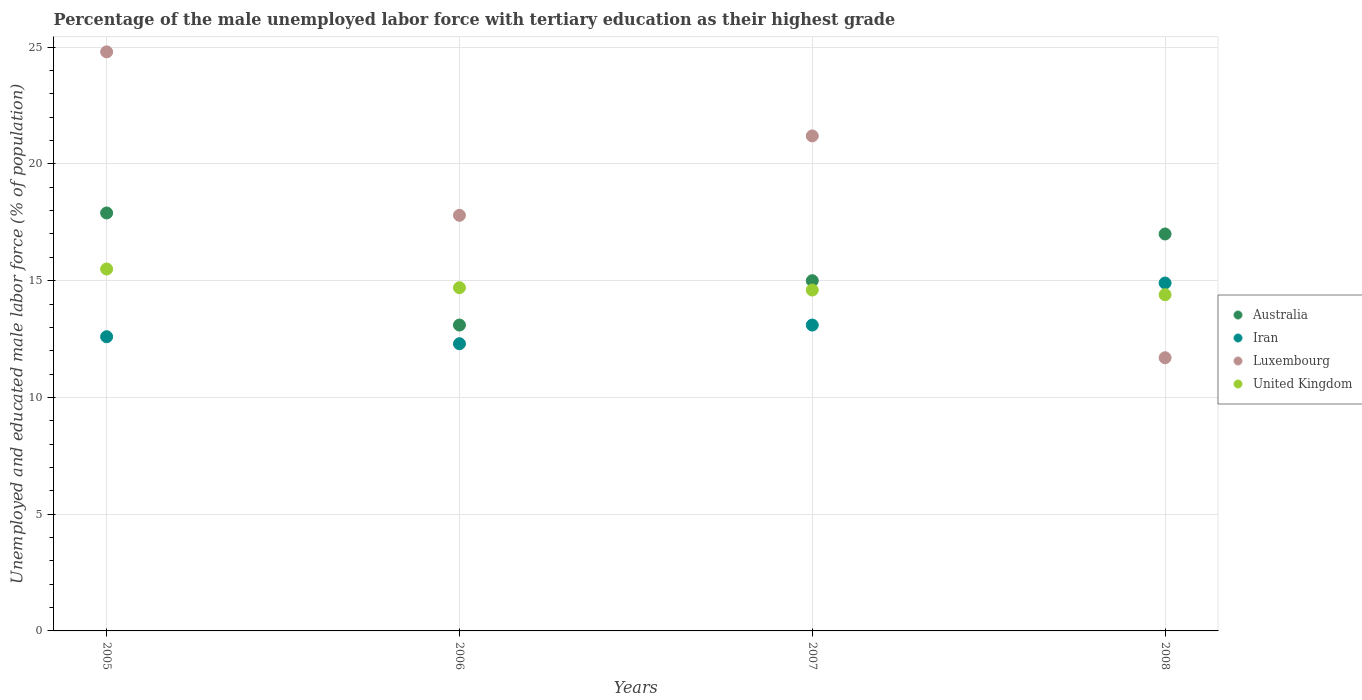How many different coloured dotlines are there?
Keep it short and to the point. 4. Is the number of dotlines equal to the number of legend labels?
Provide a short and direct response. Yes. What is the percentage of the unemployed male labor force with tertiary education in Luxembourg in 2008?
Your answer should be compact. 11.7. Across all years, what is the maximum percentage of the unemployed male labor force with tertiary education in Iran?
Make the answer very short. 14.9. Across all years, what is the minimum percentage of the unemployed male labor force with tertiary education in Iran?
Your answer should be very brief. 12.3. What is the total percentage of the unemployed male labor force with tertiary education in Iran in the graph?
Provide a succinct answer. 52.9. What is the difference between the percentage of the unemployed male labor force with tertiary education in United Kingdom in 2006 and that in 2008?
Provide a succinct answer. 0.3. What is the difference between the percentage of the unemployed male labor force with tertiary education in Iran in 2005 and the percentage of the unemployed male labor force with tertiary education in Luxembourg in 2007?
Ensure brevity in your answer.  -8.6. What is the average percentage of the unemployed male labor force with tertiary education in Australia per year?
Make the answer very short. 15.75. In the year 2008, what is the difference between the percentage of the unemployed male labor force with tertiary education in United Kingdom and percentage of the unemployed male labor force with tertiary education in Iran?
Offer a terse response. -0.5. What is the ratio of the percentage of the unemployed male labor force with tertiary education in Luxembourg in 2007 to that in 2008?
Give a very brief answer. 1.81. What is the difference between the highest and the second highest percentage of the unemployed male labor force with tertiary education in Iran?
Ensure brevity in your answer.  1.8. What is the difference between the highest and the lowest percentage of the unemployed male labor force with tertiary education in Iran?
Give a very brief answer. 2.6. Is the sum of the percentage of the unemployed male labor force with tertiary education in Luxembourg in 2006 and 2008 greater than the maximum percentage of the unemployed male labor force with tertiary education in United Kingdom across all years?
Your response must be concise. Yes. Is it the case that in every year, the sum of the percentage of the unemployed male labor force with tertiary education in United Kingdom and percentage of the unemployed male labor force with tertiary education in Luxembourg  is greater than the percentage of the unemployed male labor force with tertiary education in Australia?
Provide a succinct answer. Yes. Does the percentage of the unemployed male labor force with tertiary education in United Kingdom monotonically increase over the years?
Ensure brevity in your answer.  No. Is the percentage of the unemployed male labor force with tertiary education in Australia strictly greater than the percentage of the unemployed male labor force with tertiary education in Luxembourg over the years?
Your response must be concise. No. How many dotlines are there?
Provide a short and direct response. 4. How many years are there in the graph?
Provide a short and direct response. 4. What is the difference between two consecutive major ticks on the Y-axis?
Keep it short and to the point. 5. Are the values on the major ticks of Y-axis written in scientific E-notation?
Ensure brevity in your answer.  No. Does the graph contain grids?
Ensure brevity in your answer.  Yes. How are the legend labels stacked?
Keep it short and to the point. Vertical. What is the title of the graph?
Your answer should be very brief. Percentage of the male unemployed labor force with tertiary education as their highest grade. Does "Estonia" appear as one of the legend labels in the graph?
Give a very brief answer. No. What is the label or title of the X-axis?
Ensure brevity in your answer.  Years. What is the label or title of the Y-axis?
Your response must be concise. Unemployed and educated male labor force (% of population). What is the Unemployed and educated male labor force (% of population) of Australia in 2005?
Provide a succinct answer. 17.9. What is the Unemployed and educated male labor force (% of population) in Iran in 2005?
Your response must be concise. 12.6. What is the Unemployed and educated male labor force (% of population) in Luxembourg in 2005?
Give a very brief answer. 24.8. What is the Unemployed and educated male labor force (% of population) in United Kingdom in 2005?
Keep it short and to the point. 15.5. What is the Unemployed and educated male labor force (% of population) of Australia in 2006?
Ensure brevity in your answer.  13.1. What is the Unemployed and educated male labor force (% of population) in Iran in 2006?
Provide a short and direct response. 12.3. What is the Unemployed and educated male labor force (% of population) of Luxembourg in 2006?
Provide a succinct answer. 17.8. What is the Unemployed and educated male labor force (% of population) of United Kingdom in 2006?
Make the answer very short. 14.7. What is the Unemployed and educated male labor force (% of population) in Iran in 2007?
Ensure brevity in your answer.  13.1. What is the Unemployed and educated male labor force (% of population) of Luxembourg in 2007?
Offer a terse response. 21.2. What is the Unemployed and educated male labor force (% of population) of United Kingdom in 2007?
Make the answer very short. 14.6. What is the Unemployed and educated male labor force (% of population) of Australia in 2008?
Offer a very short reply. 17. What is the Unemployed and educated male labor force (% of population) of Iran in 2008?
Your answer should be very brief. 14.9. What is the Unemployed and educated male labor force (% of population) in Luxembourg in 2008?
Give a very brief answer. 11.7. What is the Unemployed and educated male labor force (% of population) of United Kingdom in 2008?
Offer a very short reply. 14.4. Across all years, what is the maximum Unemployed and educated male labor force (% of population) in Australia?
Your response must be concise. 17.9. Across all years, what is the maximum Unemployed and educated male labor force (% of population) in Iran?
Your response must be concise. 14.9. Across all years, what is the maximum Unemployed and educated male labor force (% of population) in Luxembourg?
Keep it short and to the point. 24.8. Across all years, what is the maximum Unemployed and educated male labor force (% of population) of United Kingdom?
Your answer should be compact. 15.5. Across all years, what is the minimum Unemployed and educated male labor force (% of population) of Australia?
Give a very brief answer. 13.1. Across all years, what is the minimum Unemployed and educated male labor force (% of population) in Iran?
Keep it short and to the point. 12.3. Across all years, what is the minimum Unemployed and educated male labor force (% of population) in Luxembourg?
Make the answer very short. 11.7. Across all years, what is the minimum Unemployed and educated male labor force (% of population) of United Kingdom?
Keep it short and to the point. 14.4. What is the total Unemployed and educated male labor force (% of population) of Australia in the graph?
Provide a short and direct response. 63. What is the total Unemployed and educated male labor force (% of population) of Iran in the graph?
Offer a terse response. 52.9. What is the total Unemployed and educated male labor force (% of population) in Luxembourg in the graph?
Provide a succinct answer. 75.5. What is the total Unemployed and educated male labor force (% of population) in United Kingdom in the graph?
Provide a succinct answer. 59.2. What is the difference between the Unemployed and educated male labor force (% of population) of Australia in 2005 and that in 2006?
Make the answer very short. 4.8. What is the difference between the Unemployed and educated male labor force (% of population) of United Kingdom in 2005 and that in 2007?
Keep it short and to the point. 0.9. What is the difference between the Unemployed and educated male labor force (% of population) of Australia in 2005 and that in 2008?
Keep it short and to the point. 0.9. What is the difference between the Unemployed and educated male labor force (% of population) of Luxembourg in 2005 and that in 2008?
Give a very brief answer. 13.1. What is the difference between the Unemployed and educated male labor force (% of population) in Iran in 2005 and the Unemployed and educated male labor force (% of population) in Luxembourg in 2006?
Provide a succinct answer. -5.2. What is the difference between the Unemployed and educated male labor force (% of population) of Luxembourg in 2005 and the Unemployed and educated male labor force (% of population) of United Kingdom in 2006?
Keep it short and to the point. 10.1. What is the difference between the Unemployed and educated male labor force (% of population) in Australia in 2005 and the Unemployed and educated male labor force (% of population) in Iran in 2007?
Keep it short and to the point. 4.8. What is the difference between the Unemployed and educated male labor force (% of population) in Australia in 2005 and the Unemployed and educated male labor force (% of population) in Luxembourg in 2007?
Your answer should be compact. -3.3. What is the difference between the Unemployed and educated male labor force (% of population) of Australia in 2005 and the Unemployed and educated male labor force (% of population) of United Kingdom in 2007?
Ensure brevity in your answer.  3.3. What is the difference between the Unemployed and educated male labor force (% of population) in Iran in 2005 and the Unemployed and educated male labor force (% of population) in United Kingdom in 2007?
Offer a terse response. -2. What is the difference between the Unemployed and educated male labor force (% of population) of Australia in 2005 and the Unemployed and educated male labor force (% of population) of Iran in 2008?
Offer a very short reply. 3. What is the difference between the Unemployed and educated male labor force (% of population) in Australia in 2005 and the Unemployed and educated male labor force (% of population) in United Kingdom in 2008?
Your answer should be very brief. 3.5. What is the difference between the Unemployed and educated male labor force (% of population) in Australia in 2006 and the Unemployed and educated male labor force (% of population) in Iran in 2007?
Keep it short and to the point. 0. What is the difference between the Unemployed and educated male labor force (% of population) of Luxembourg in 2006 and the Unemployed and educated male labor force (% of population) of United Kingdom in 2008?
Provide a short and direct response. 3.4. What is the difference between the Unemployed and educated male labor force (% of population) in Australia in 2007 and the Unemployed and educated male labor force (% of population) in Luxembourg in 2008?
Your response must be concise. 3.3. What is the difference between the Unemployed and educated male labor force (% of population) of Australia in 2007 and the Unemployed and educated male labor force (% of population) of United Kingdom in 2008?
Your response must be concise. 0.6. What is the difference between the Unemployed and educated male labor force (% of population) in Iran in 2007 and the Unemployed and educated male labor force (% of population) in Luxembourg in 2008?
Make the answer very short. 1.4. What is the difference between the Unemployed and educated male labor force (% of population) in Iran in 2007 and the Unemployed and educated male labor force (% of population) in United Kingdom in 2008?
Provide a succinct answer. -1.3. What is the difference between the Unemployed and educated male labor force (% of population) of Luxembourg in 2007 and the Unemployed and educated male labor force (% of population) of United Kingdom in 2008?
Offer a terse response. 6.8. What is the average Unemployed and educated male labor force (% of population) in Australia per year?
Your answer should be very brief. 15.75. What is the average Unemployed and educated male labor force (% of population) of Iran per year?
Give a very brief answer. 13.22. What is the average Unemployed and educated male labor force (% of population) of Luxembourg per year?
Make the answer very short. 18.88. What is the average Unemployed and educated male labor force (% of population) in United Kingdom per year?
Your answer should be compact. 14.8. In the year 2005, what is the difference between the Unemployed and educated male labor force (% of population) in Australia and Unemployed and educated male labor force (% of population) in Iran?
Ensure brevity in your answer.  5.3. In the year 2005, what is the difference between the Unemployed and educated male labor force (% of population) in Australia and Unemployed and educated male labor force (% of population) in Luxembourg?
Provide a short and direct response. -6.9. In the year 2005, what is the difference between the Unemployed and educated male labor force (% of population) in Australia and Unemployed and educated male labor force (% of population) in United Kingdom?
Your answer should be compact. 2.4. In the year 2005, what is the difference between the Unemployed and educated male labor force (% of population) of Iran and Unemployed and educated male labor force (% of population) of Luxembourg?
Offer a very short reply. -12.2. In the year 2005, what is the difference between the Unemployed and educated male labor force (% of population) of Iran and Unemployed and educated male labor force (% of population) of United Kingdom?
Provide a short and direct response. -2.9. In the year 2006, what is the difference between the Unemployed and educated male labor force (% of population) of Australia and Unemployed and educated male labor force (% of population) of Iran?
Your answer should be very brief. 0.8. In the year 2006, what is the difference between the Unemployed and educated male labor force (% of population) of Iran and Unemployed and educated male labor force (% of population) of United Kingdom?
Keep it short and to the point. -2.4. In the year 2006, what is the difference between the Unemployed and educated male labor force (% of population) of Luxembourg and Unemployed and educated male labor force (% of population) of United Kingdom?
Your answer should be very brief. 3.1. In the year 2007, what is the difference between the Unemployed and educated male labor force (% of population) in Australia and Unemployed and educated male labor force (% of population) in Luxembourg?
Make the answer very short. -6.2. In the year 2007, what is the difference between the Unemployed and educated male labor force (% of population) of Luxembourg and Unemployed and educated male labor force (% of population) of United Kingdom?
Give a very brief answer. 6.6. In the year 2008, what is the difference between the Unemployed and educated male labor force (% of population) in Iran and Unemployed and educated male labor force (% of population) in Luxembourg?
Give a very brief answer. 3.2. In the year 2008, what is the difference between the Unemployed and educated male labor force (% of population) in Luxembourg and Unemployed and educated male labor force (% of population) in United Kingdom?
Make the answer very short. -2.7. What is the ratio of the Unemployed and educated male labor force (% of population) of Australia in 2005 to that in 2006?
Ensure brevity in your answer.  1.37. What is the ratio of the Unemployed and educated male labor force (% of population) in Iran in 2005 to that in 2006?
Your answer should be very brief. 1.02. What is the ratio of the Unemployed and educated male labor force (% of population) in Luxembourg in 2005 to that in 2006?
Your answer should be very brief. 1.39. What is the ratio of the Unemployed and educated male labor force (% of population) in United Kingdom in 2005 to that in 2006?
Provide a succinct answer. 1.05. What is the ratio of the Unemployed and educated male labor force (% of population) of Australia in 2005 to that in 2007?
Provide a succinct answer. 1.19. What is the ratio of the Unemployed and educated male labor force (% of population) in Iran in 2005 to that in 2007?
Provide a succinct answer. 0.96. What is the ratio of the Unemployed and educated male labor force (% of population) in Luxembourg in 2005 to that in 2007?
Give a very brief answer. 1.17. What is the ratio of the Unemployed and educated male labor force (% of population) of United Kingdom in 2005 to that in 2007?
Give a very brief answer. 1.06. What is the ratio of the Unemployed and educated male labor force (% of population) in Australia in 2005 to that in 2008?
Your answer should be very brief. 1.05. What is the ratio of the Unemployed and educated male labor force (% of population) in Iran in 2005 to that in 2008?
Your answer should be compact. 0.85. What is the ratio of the Unemployed and educated male labor force (% of population) of Luxembourg in 2005 to that in 2008?
Your answer should be compact. 2.12. What is the ratio of the Unemployed and educated male labor force (% of population) of United Kingdom in 2005 to that in 2008?
Give a very brief answer. 1.08. What is the ratio of the Unemployed and educated male labor force (% of population) in Australia in 2006 to that in 2007?
Provide a succinct answer. 0.87. What is the ratio of the Unemployed and educated male labor force (% of population) of Iran in 2006 to that in 2007?
Offer a terse response. 0.94. What is the ratio of the Unemployed and educated male labor force (% of population) in Luxembourg in 2006 to that in 2007?
Your answer should be very brief. 0.84. What is the ratio of the Unemployed and educated male labor force (% of population) of United Kingdom in 2006 to that in 2007?
Your answer should be very brief. 1.01. What is the ratio of the Unemployed and educated male labor force (% of population) in Australia in 2006 to that in 2008?
Your response must be concise. 0.77. What is the ratio of the Unemployed and educated male labor force (% of population) in Iran in 2006 to that in 2008?
Give a very brief answer. 0.83. What is the ratio of the Unemployed and educated male labor force (% of population) of Luxembourg in 2006 to that in 2008?
Keep it short and to the point. 1.52. What is the ratio of the Unemployed and educated male labor force (% of population) of United Kingdom in 2006 to that in 2008?
Make the answer very short. 1.02. What is the ratio of the Unemployed and educated male labor force (% of population) in Australia in 2007 to that in 2008?
Ensure brevity in your answer.  0.88. What is the ratio of the Unemployed and educated male labor force (% of population) of Iran in 2007 to that in 2008?
Provide a short and direct response. 0.88. What is the ratio of the Unemployed and educated male labor force (% of population) of Luxembourg in 2007 to that in 2008?
Offer a very short reply. 1.81. What is the ratio of the Unemployed and educated male labor force (% of population) of United Kingdom in 2007 to that in 2008?
Offer a terse response. 1.01. What is the difference between the highest and the second highest Unemployed and educated male labor force (% of population) in Australia?
Provide a short and direct response. 0.9. 